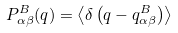<formula> <loc_0><loc_0><loc_500><loc_500>P ^ { B } _ { \alpha \beta } ( q ) = \left \langle \delta \left ( q - q ^ { B } _ { \alpha \beta } \right ) \right \rangle</formula> 